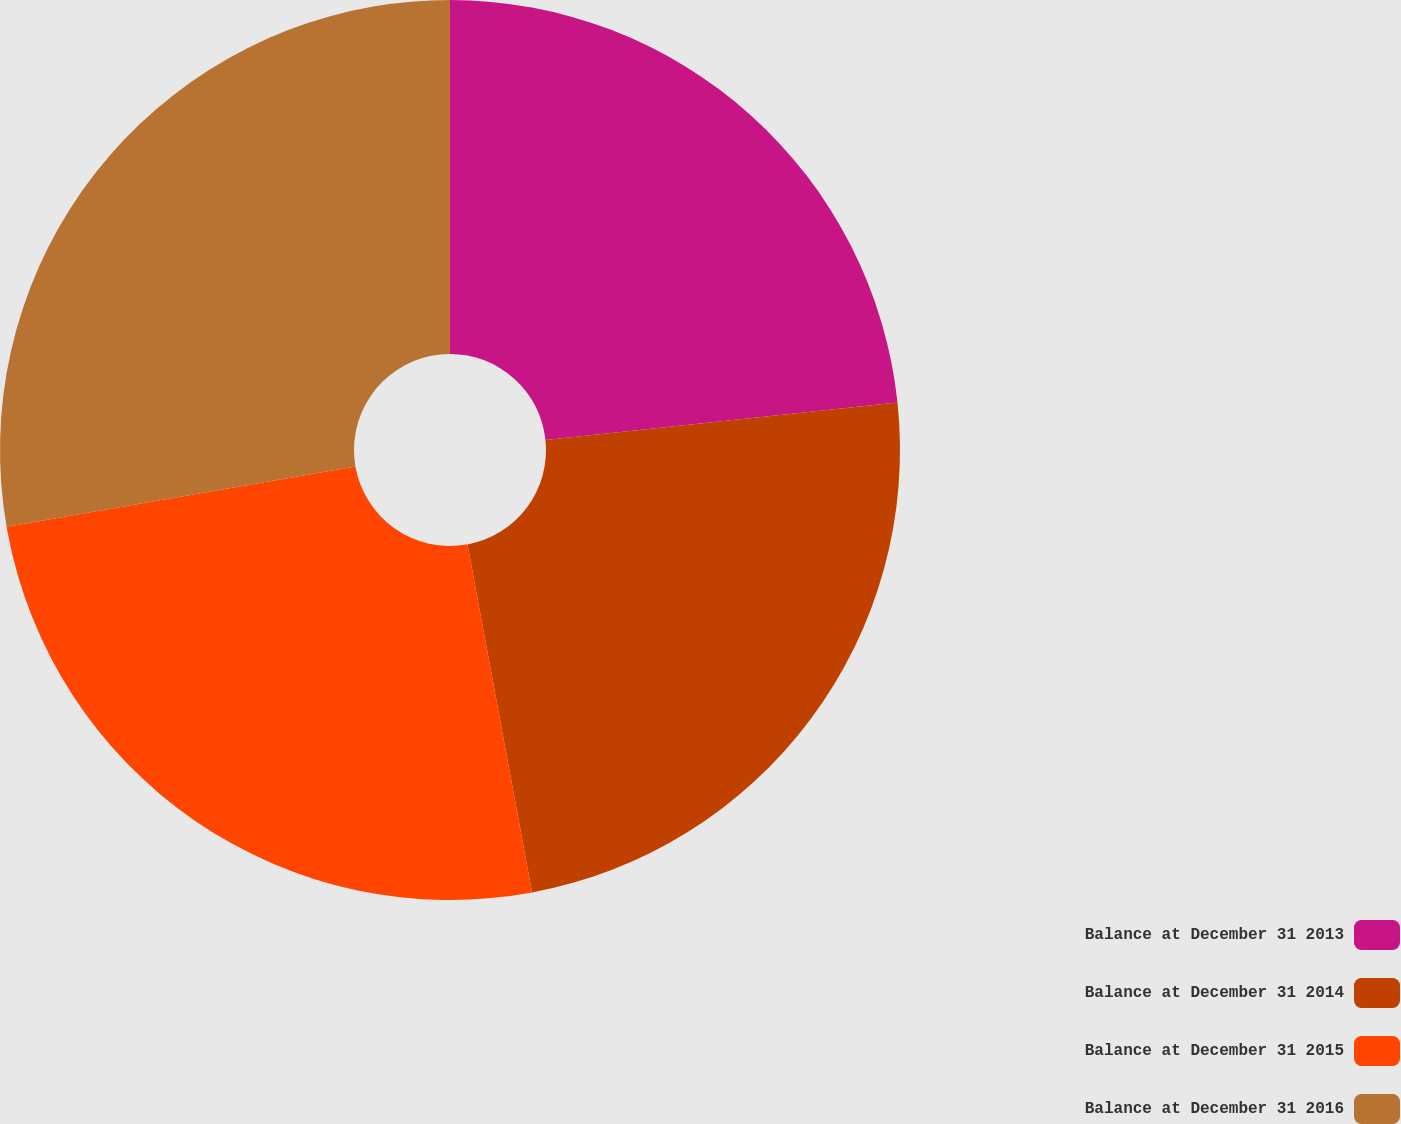Convert chart to OTSL. <chart><loc_0><loc_0><loc_500><loc_500><pie_chart><fcel>Balance at December 31 2013<fcel>Balance at December 31 2014<fcel>Balance at December 31 2015<fcel>Balance at December 31 2016<nl><fcel>23.32%<fcel>23.76%<fcel>25.19%<fcel>27.73%<nl></chart> 